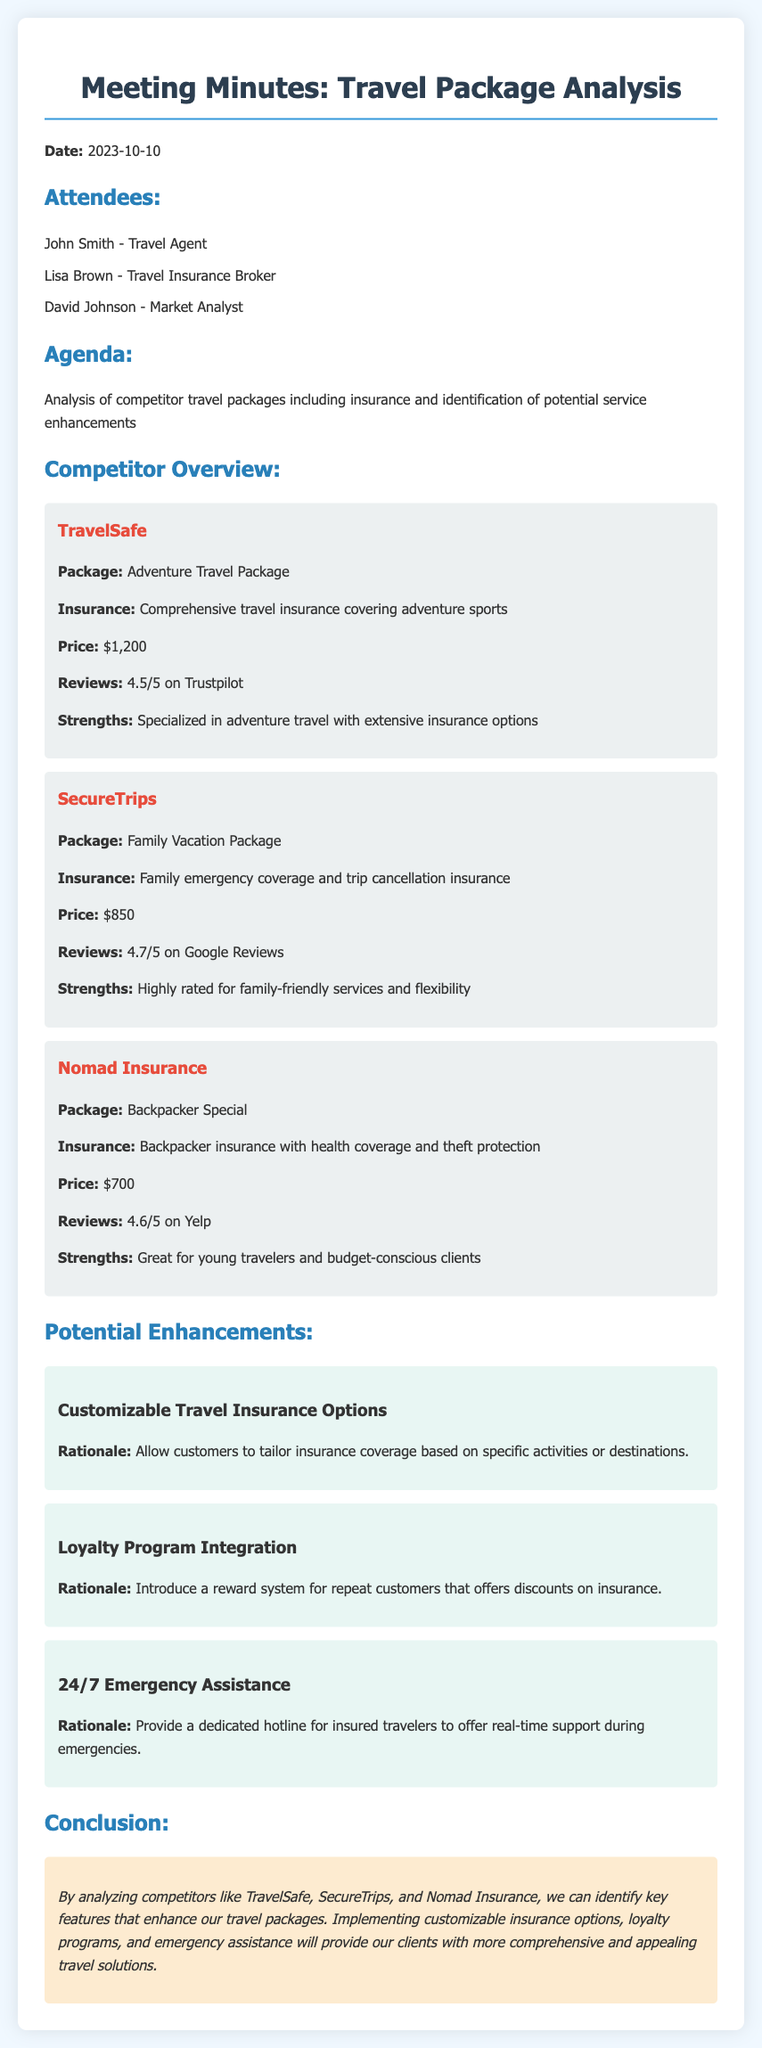What date was the meeting held? The meeting date is clearly stated in the document under the "Date" section.
Answer: 2023-10-10 Who is the market analyst present in the meeting? The participants are listed in the "Attendees" section, mentioning each person's role.
Answer: David Johnson What is the price of the Adventure Travel Package offered by TravelSafe? The price of the package is specified in the competitor's overview for TravelSafe.
Answer: $1,200 What is a strength of SecureTrips? Each competitor's strengths are highlighted in their respective sections, specifically mentioning SecureTrips.
Answer: Highly rated for family-friendly services and flexibility How many enhancements are proposed in the meeting? The enhancements section lists the number of different proposals for service improvement.
Answer: 3 What is one rationale for the customizable travel insurance options? The enhancements include rationales explaining the benefits of each proposed service improvement.
Answer: Allow customers to tailor insurance coverage based on specific activities or destinations Who discussed the potential enhancements during the meeting? The document specifies the attendees, including their roles, which indicates who participated in the discussion.
Answer: John Smith, Lisa Brown, David Johnson What feedback mechanism is indicated for travelers in case of emergencies? The document describes the enhancements and mentions a specific feature related to emergency support in the proposal.
Answer: 24/7 Emergency Assistance What review score did Nomad Insurance receive on Yelp? The document provides customer reviews for each competitor, including Nomad Insurance's rating.
Answer: 4.6/5 